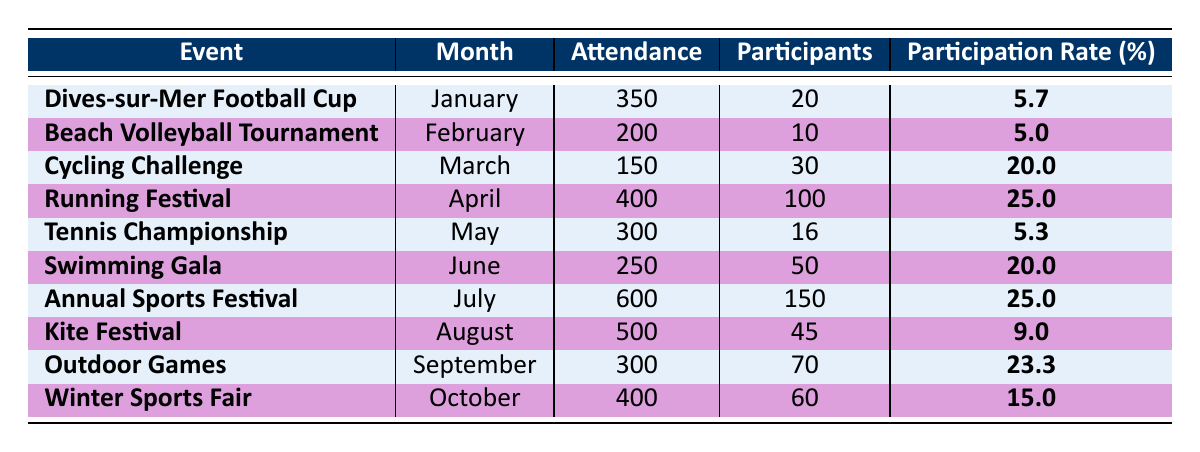What was the attendance for the Dives-sur-Mer Running Festival? The table shows that the attendance for the Dives-sur-Mer Running Festival in April 2023 was 400.
Answer: 400 What is the participation rate for the Dives-sur-Mer Swimming Gala in June? According to the table, the participation rate for the Dives-sur-Mer Swimming Gala is listed as 20.0%.
Answer: 20.0% Which event had the highest attendance in Dives-sur-Mer in 2023? The highest attendance recorded in the table is for the Dives-sur-Mer Annual Sports Festival in July, with 600 attendees.
Answer: 600 Is the participation rate for the Dives-sur-Mer Kite Festival greater than the participation rate for the Tennis Championship? The participation rate for the Kite Festival is 9.0%, while for the Tennis Championship, it is 5.3%. Since 9.0% is greater than 5.3%, the answer is yes.
Answer: Yes What is the total attendance for the events held in the first half of 2023 (up to June)? The total attendance for the events in January (350), February (200), March (150), April (400), May (300), and June (250) is calculated as 350 + 200 + 150 + 400 + 300 + 250 = 1650.
Answer: 1650 What is the average participation rate for all events listed? To find the average participation rate, add all the participation rates: 5.7 + 5.0 + 20.0 + 25.0 + 5.3 + 20.0 + 25.0 + 9.0 + 23.3 + 15.0 = 134.3. Then divide this by the number of events (10): 134.3 / 10 = 13.43.
Answer: 13.43 Is the attendance for the January event higher than the attendance for the February event? The attendance for the January event (350) is greater than the February event (200), so the statement is true.
Answer: Yes What is the difference in the number of participants between the Annual Sports Festival and the Cycling Challenge? The Annual Sports Festival had 150 participants and the Cycling Challenge had 30 participants. The difference is 150 - 30 = 120.
Answer: 120 How many events had a participation rate of more than 20%? The events with a participation rate of more than 20% are the Running Festival (25.0%), Annual Sports Festival (25.0%), Swimming Gala (20.0%), and Outdoor Games (23.3%). This totals to four events.
Answer: 4 